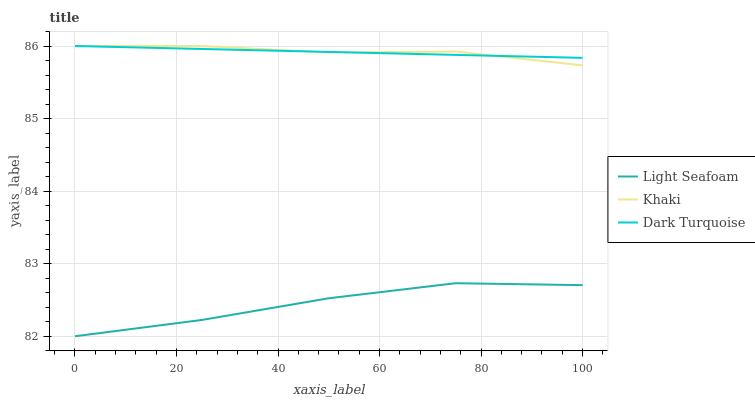Does Light Seafoam have the minimum area under the curve?
Answer yes or no. Yes. Does Khaki have the maximum area under the curve?
Answer yes or no. Yes. Does Khaki have the minimum area under the curve?
Answer yes or no. No. Does Light Seafoam have the maximum area under the curve?
Answer yes or no. No. Is Dark Turquoise the smoothest?
Answer yes or no. Yes. Is Light Seafoam the roughest?
Answer yes or no. Yes. Is Khaki the smoothest?
Answer yes or no. No. Is Khaki the roughest?
Answer yes or no. No. Does Light Seafoam have the lowest value?
Answer yes or no. Yes. Does Khaki have the lowest value?
Answer yes or no. No. Does Khaki have the highest value?
Answer yes or no. Yes. Does Light Seafoam have the highest value?
Answer yes or no. No. Is Light Seafoam less than Dark Turquoise?
Answer yes or no. Yes. Is Dark Turquoise greater than Light Seafoam?
Answer yes or no. Yes. Does Dark Turquoise intersect Khaki?
Answer yes or no. Yes. Is Dark Turquoise less than Khaki?
Answer yes or no. No. Is Dark Turquoise greater than Khaki?
Answer yes or no. No. Does Light Seafoam intersect Dark Turquoise?
Answer yes or no. No. 